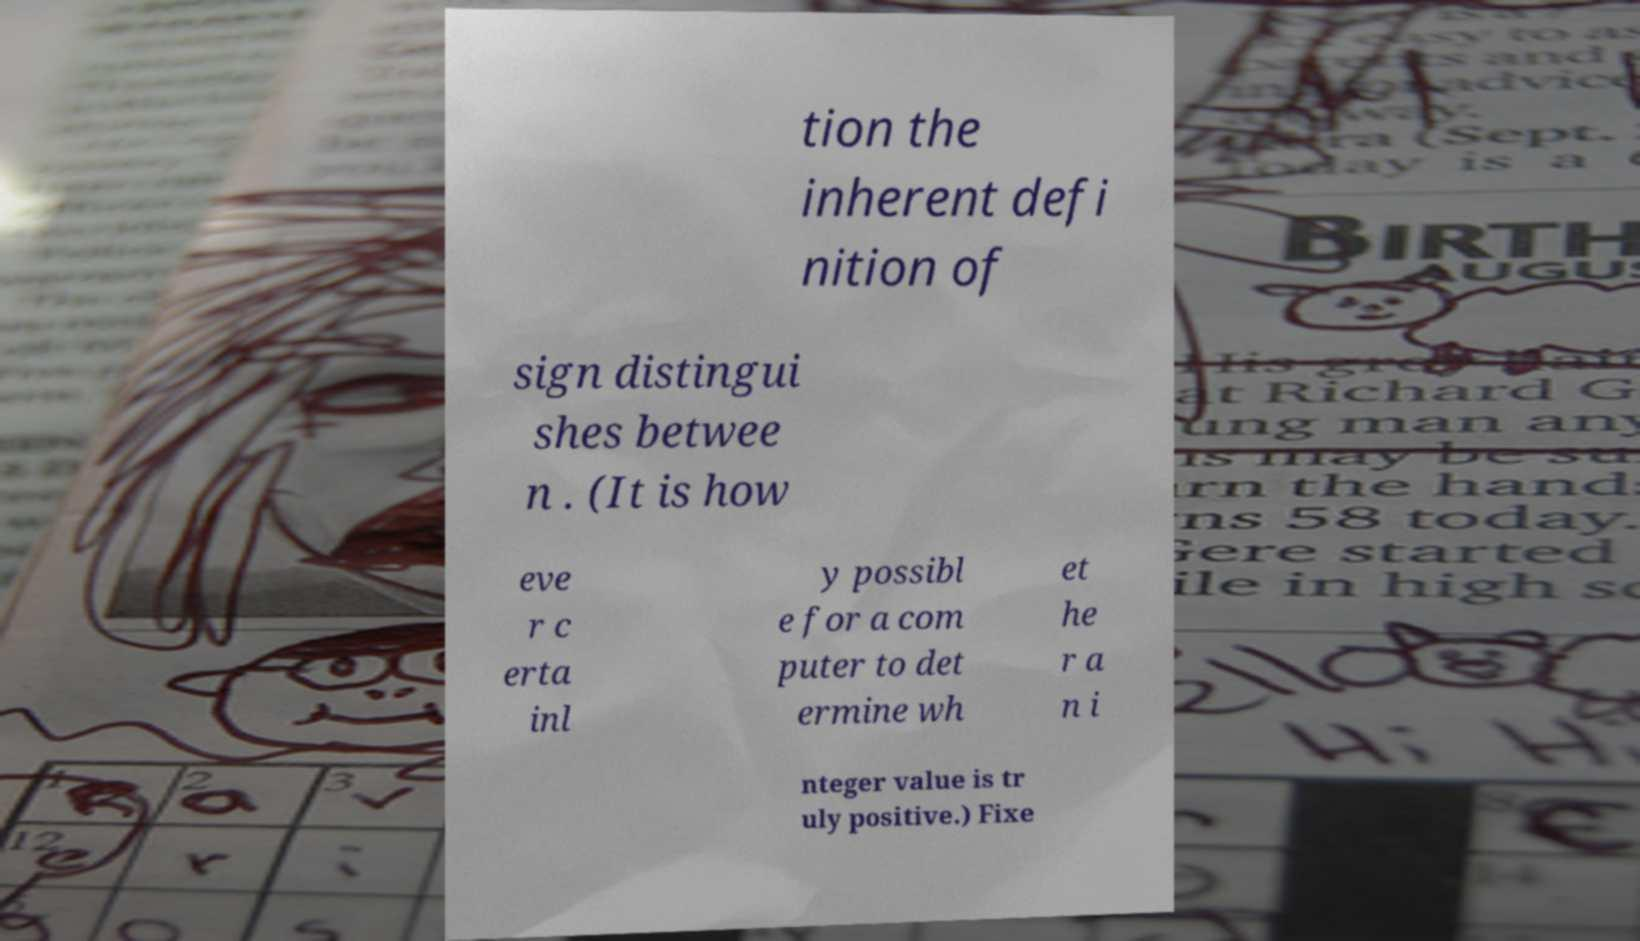Could you extract and type out the text from this image? tion the inherent defi nition of sign distingui shes betwee n . (It is how eve r c erta inl y possibl e for a com puter to det ermine wh et he r a n i nteger value is tr uly positive.) Fixe 